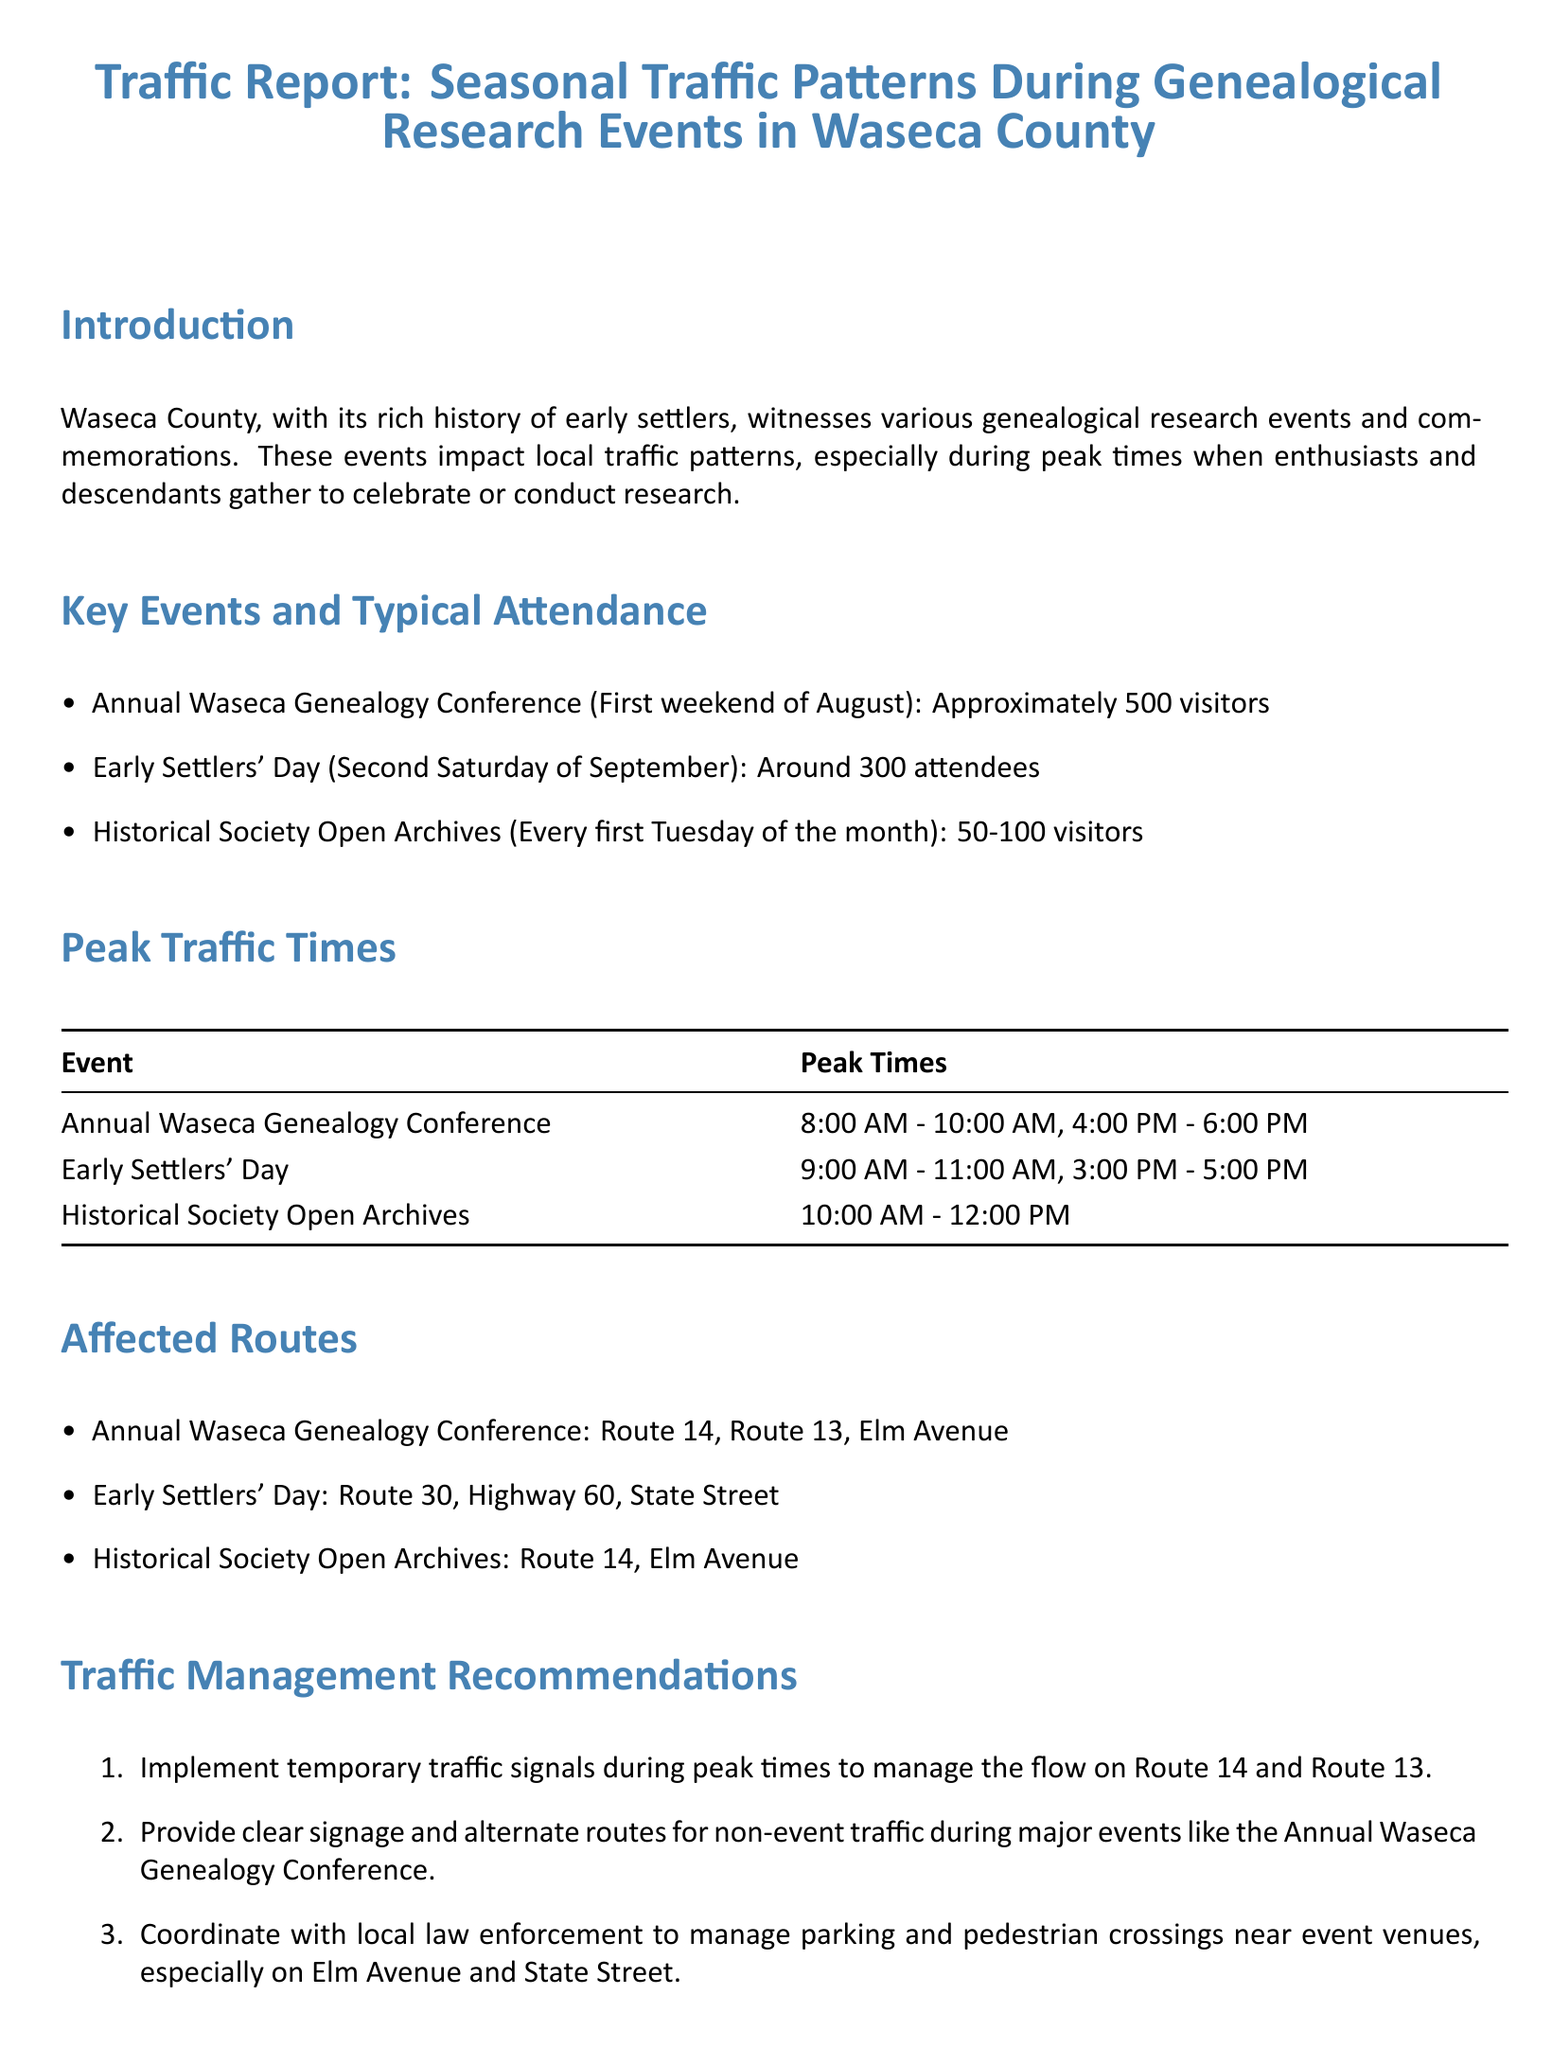What is the attendance for the Annual Waseca Genealogy Conference? The document states that approximately 500 visitors attend this event.
Answer: 500 visitors What are the peak times for Early Settlers' Day? According to the report, the peak times are 9:00 AM - 11:00 AM and 3:00 PM - 5:00 PM.
Answer: 9:00 AM - 11:00 AM, 3:00 PM - 5:00 PM Which route is affected by the Historical Society Open Archives? The document lists Route 14 and Elm Avenue as affected routes for this event.
Answer: Route 14, Elm Avenue What traffic management recommendation is suggested for Route 14? The report recommends implementing temporary traffic signals to manage flow during peak times.
Answer: Temporary traffic signals How many typical attendees are expected for the Historical Society Open Archives? The document indicates that there will be 50-100 visitors for this event.
Answer: 50-100 visitors What is the date for Early Settlers' Day? The report specifies that Early Settlers' Day occurs on the second Saturday of September.
Answer: Second Saturday of September What is the peak time range for the Annual Waseca Genealogy Conference? The peak times for this conference are from 8:00 AM - 10:00 AM and 4:00 PM - 6:00 PM.
Answer: 8:00 AM - 10:00 AM, 4:00 PM - 6:00 PM Which routes are affected on Early Settlers' Day? The affected routes on this day include Route 30, Highway 60, and State Street, according to the document.
Answer: Route 30, Highway 60, State Street 